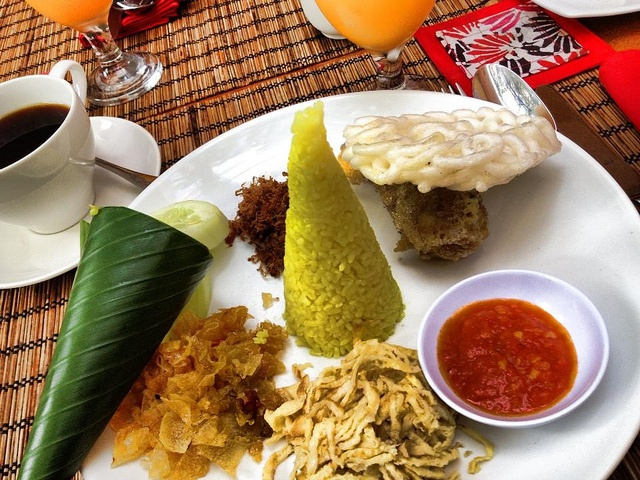Describe the objects in this image and their specific colors. I can see dining table in lightgray, black, maroon, and olive tones, bowl in maroon, lavender, and darkgray tones, cup in maroon, gray, black, tan, and lightgray tones, wine glass in maroon, red, orange, and gray tones, and wine glass in maroon, orange, red, and brown tones in this image. 